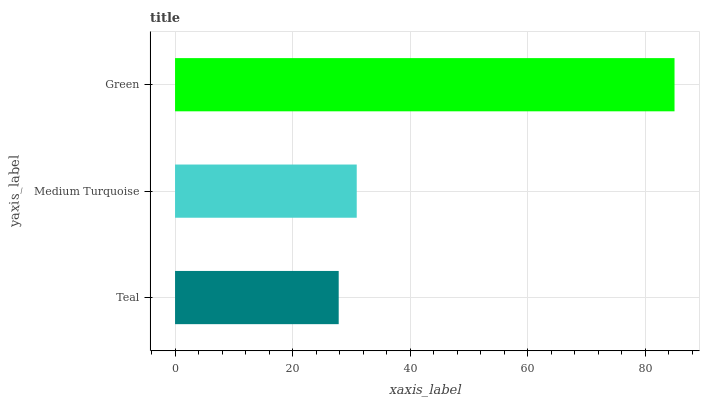Is Teal the minimum?
Answer yes or no. Yes. Is Green the maximum?
Answer yes or no. Yes. Is Medium Turquoise the minimum?
Answer yes or no. No. Is Medium Turquoise the maximum?
Answer yes or no. No. Is Medium Turquoise greater than Teal?
Answer yes or no. Yes. Is Teal less than Medium Turquoise?
Answer yes or no. Yes. Is Teal greater than Medium Turquoise?
Answer yes or no. No. Is Medium Turquoise less than Teal?
Answer yes or no. No. Is Medium Turquoise the high median?
Answer yes or no. Yes. Is Medium Turquoise the low median?
Answer yes or no. Yes. Is Teal the high median?
Answer yes or no. No. Is Teal the low median?
Answer yes or no. No. 